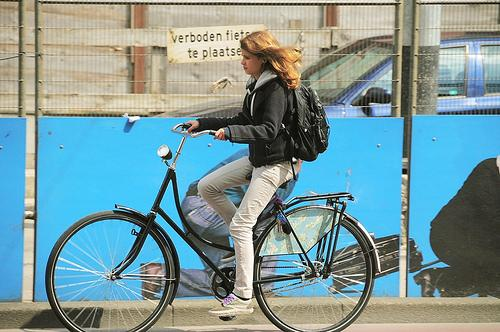Give a brief description of the overall scene taking place in the image. A girl in a black jacket and white pants is riding a bike with black tires on a sidewalk near a fence with a white sign and blue car parked behind it. Describe the setting of the image, including the background elements and colors. The image is set outdoors on a sidewalk near a wire fence with a white sign, with a blue car parked behind the fence and a blue graphic on it. Mention a detail about the girl's appearance that stands out, along with the action she's performing. The girl has reddish-brown hair and is riding a bicycle with black tires on a sidewalk near a fence. Identify the color of the girl's jacket, her pants, and her shoes. Her jacket is black, her pants are white, and her shoes are white with purple laces. Describe an accessory the girl in the image is wearing and its color. The girl is wearing a black backpack on her back while riding her bicycle. What is the primary activity illustrated by the person in the image? Riding a bike on the sidewalk near a fence and a parked car. Mention two prominent objects in the image and describe their appearance briefly. A white sign with black lettering attached to a fence, and a girl wearing a black backpack while riding a bicycle with black tires. State the main focus of the image in a single, concise sentence. A girl wearing a black jacket and white pants rides a bicycle with black tires on a sidewalk. Mention the color of the bike tires and a detail about the bike's features. The tires are black and the bike has a small headlight on the front. Explain the possible purpose of the white sign on the fence. The white sign on the fence may have a foreign language message or an advertisement, with black lettering or graphics. 